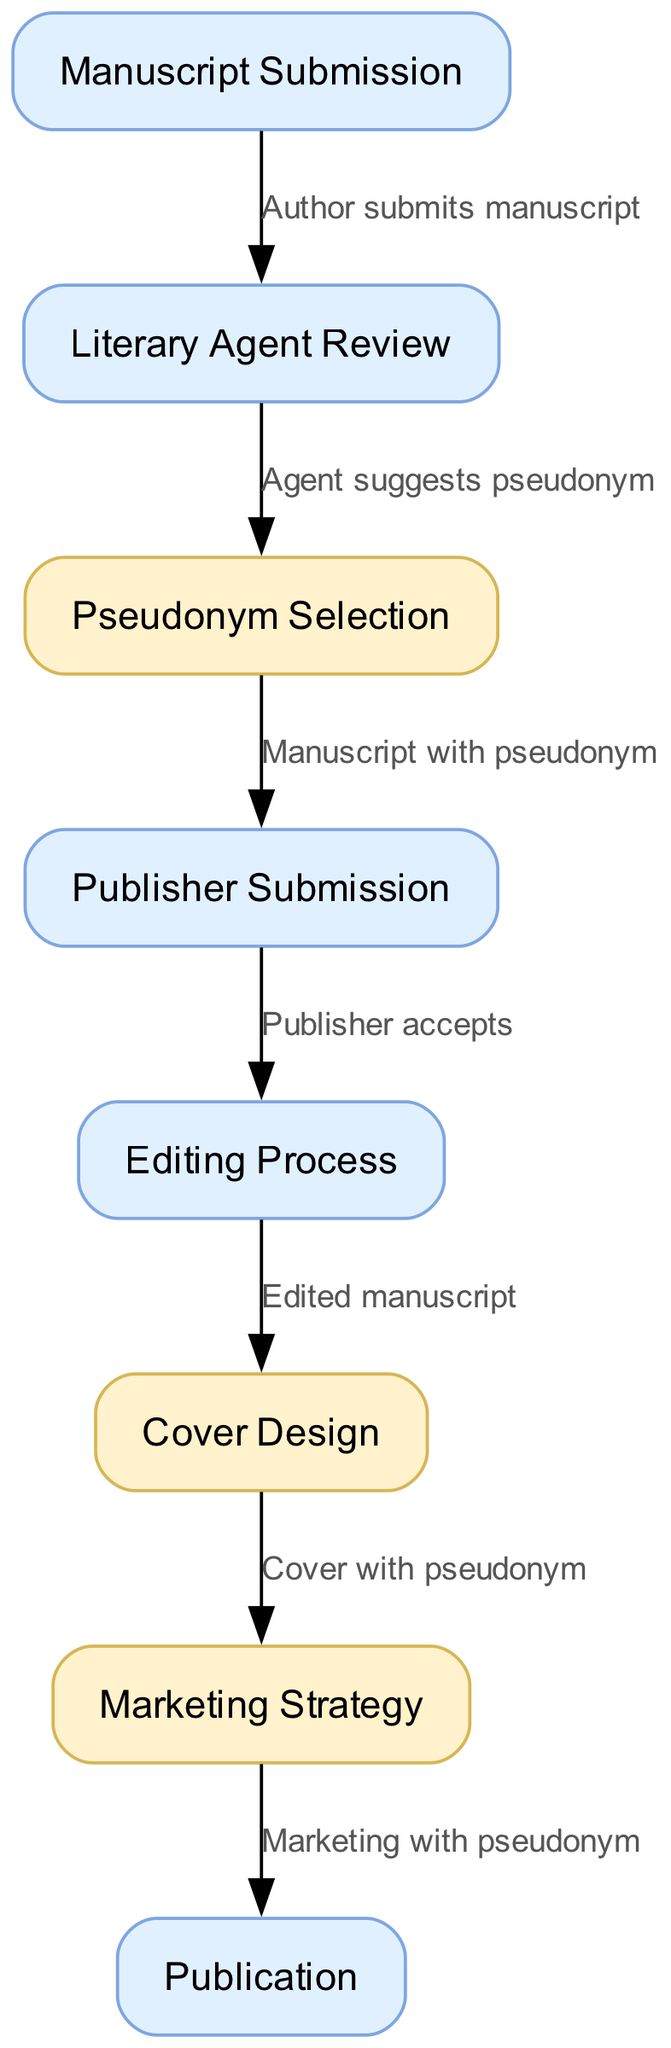What is the first step in the book lifecycle? The first step in the book lifecycle is the "Manuscript Submission" where the author submits their manuscript.
Answer: Manuscript Submission How many nodes are present in the diagram? The diagram features a total of eight nodes, each representing a different stage in the book lifecycle from submission to publication.
Answer: Eight What happens after the literary agent review? After the literary agent review, the next step is the "Pseudonym Selection," where the agent suggests a pseudonym for the manuscript.
Answer: Pseudonym Selection Which step involves cover creation? The "Cover Design" step involves creating the cover for the book, which occurs after the editing process is completed.
Answer: Cover Design At which two points is the pseudonym utilized? The pseudonym is utilized during the "Pseudonym Selection" step and the "Marketing Strategy" step, emphasizing its importance throughout the process.
Answer: Pseudonym Selection and Marketing Strategy What is the final step in the book lifecycle? The final step in the book lifecycle is "Publication," which signifies the release of the book to the public after all previous stages have been completed.
Answer: Publication How many stages involve pseudonyms? There are three stages that involve pseudonyms: "Pseudonym Selection," "Cover Design," and "Marketing Strategy," reflecting its continuous role in branding.
Answer: Three What occurs after the publisher accepts the manuscript? Following the acceptance of the manuscript by the publisher, the "Editing Process" begins, where the manuscript is edited for publication.
Answer: Editing Process What is the relationship between manuscript submission and literary agent review? The relationship is that the author submits their manuscript, which leads directly to the literary agent review as the next step in the process.
Answer: Author submits manuscript 